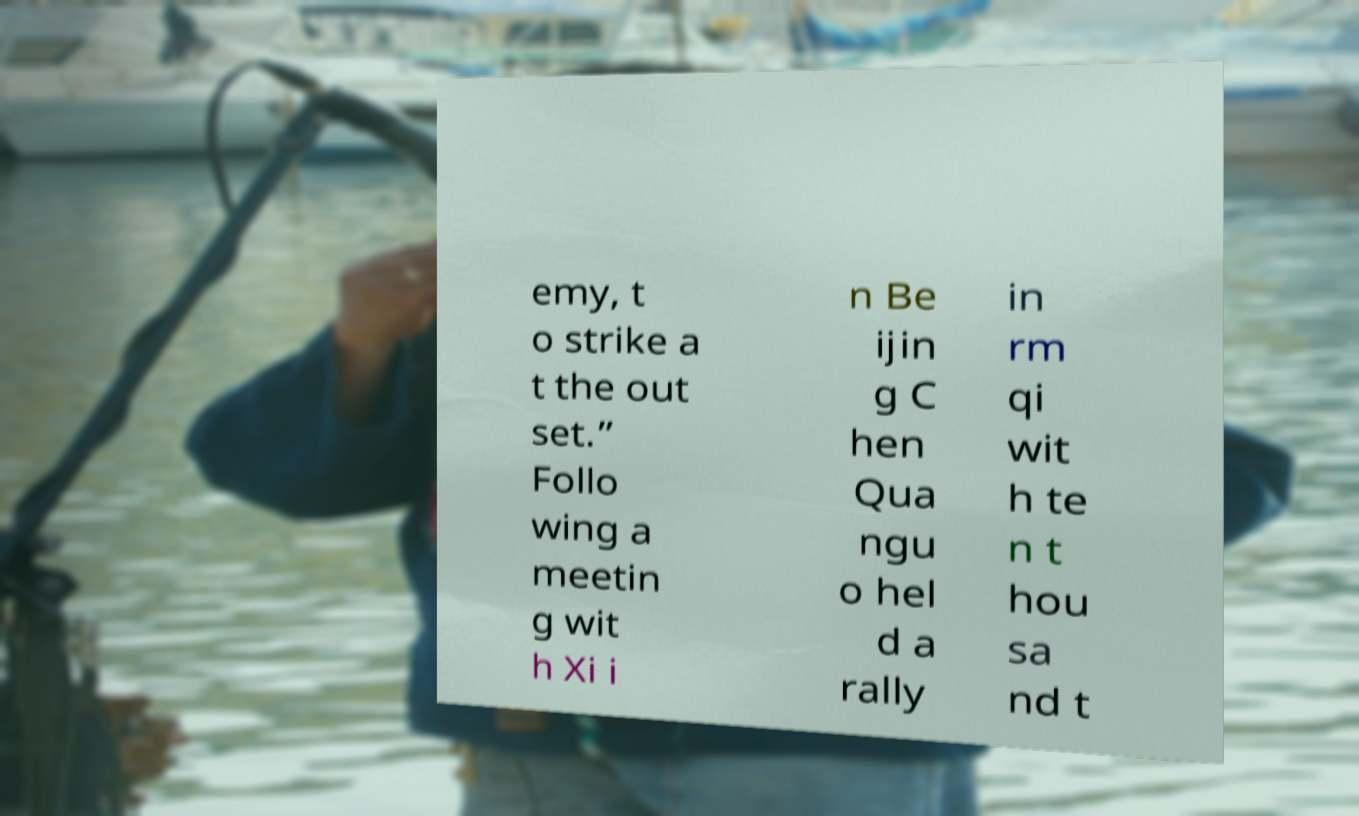Please identify and transcribe the text found in this image. emy, t o strike a t the out set.” Follo wing a meetin g wit h Xi i n Be ijin g C hen Qua ngu o hel d a rally in rm qi wit h te n t hou sa nd t 